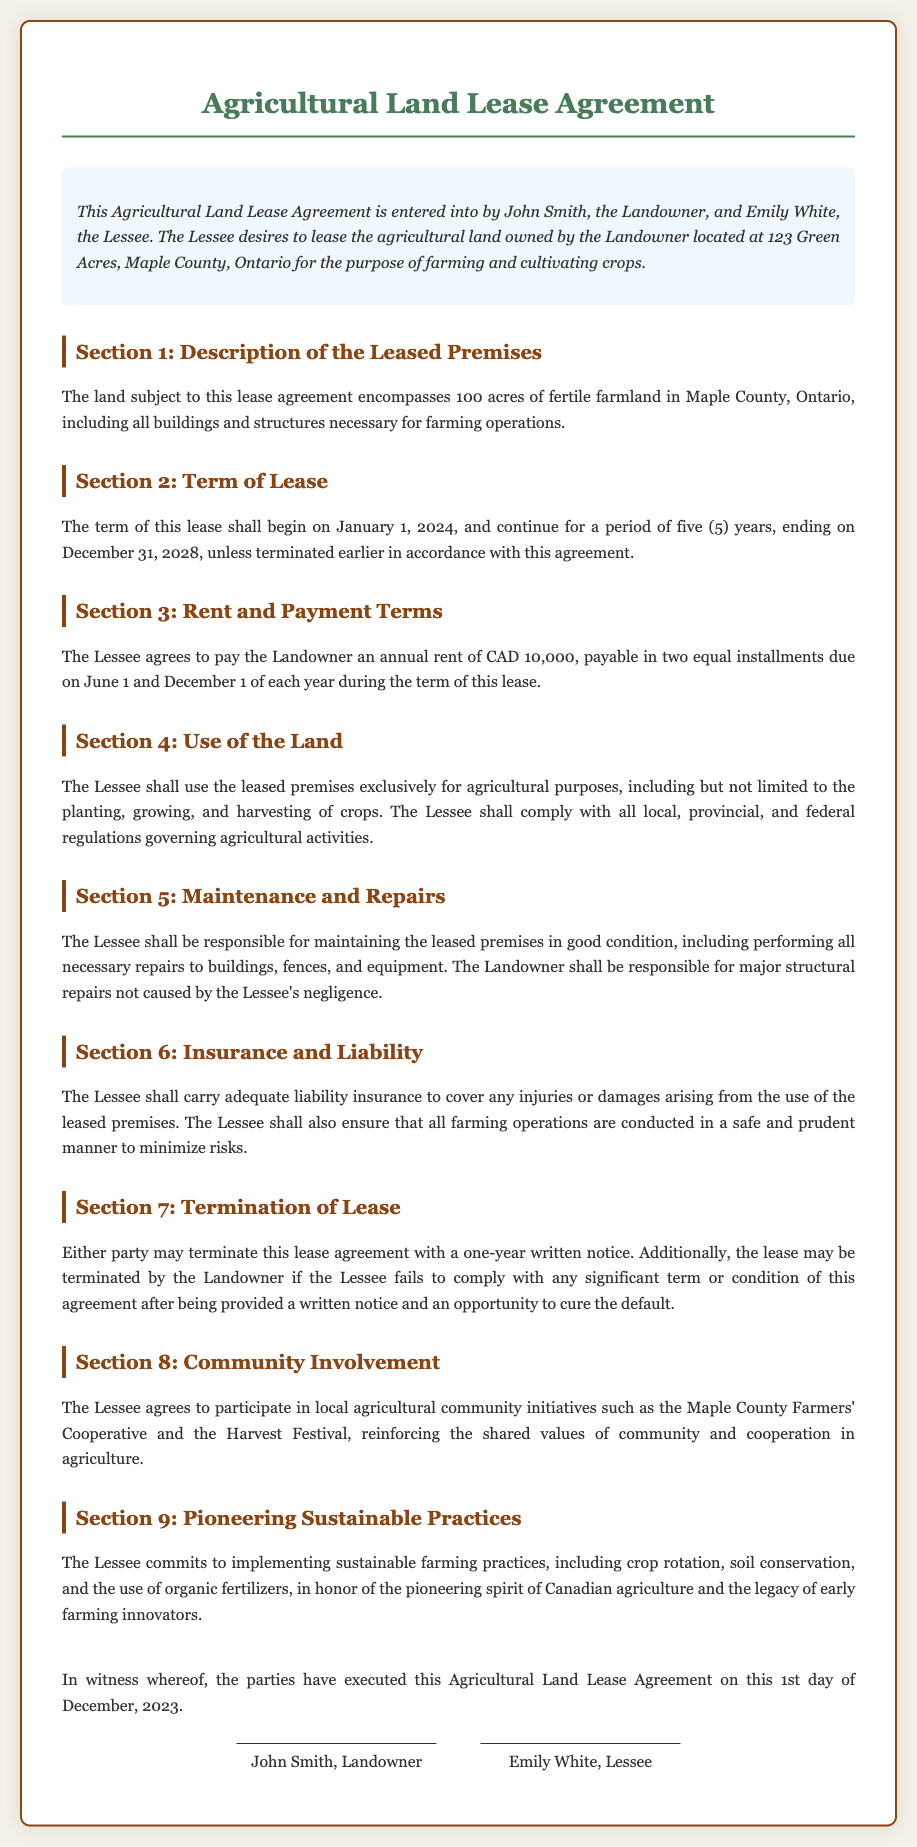What is the name of the Landowner? The Landowner's name is mentioned in the introduction of the document.
Answer: John Smith What is the term of the lease? The term of the lease is specified under the "Term of Lease" section.
Answer: five (5) years What is the annual rent amount? The annual rent amount is detailed in the "Rent and Payment Terms" section.
Answer: CAD 10,000 When does the lease start? The start date of the lease is indicated in the "Term of Lease" section.
Answer: January 1, 2024 What are the Lessee's responsibilities regarding maintenance? The Lessee's responsibilities for maintenance are outlined in the "Maintenance and Repairs" section.
Answer: Maintaining the leased premises in good condition What is required for termination of the lease? The requirements for termination are stated in the "Termination of Lease" section.
Answer: one-year written notice What community initiatives must the Lessee participate in? Community involvement expectations are presented in the "Community Involvement" section.
Answer: Maple County Farmers' Cooperative What sustainable practices must the Lessee implement? The sustainable practices that the Lessee commits to are described in the "Pioneering Sustainable Practices" section.
Answer: crop rotation, soil conservation, organic fertilizers Who are the signatories of the agreement? The signatories of the lease agreement are shown at the end of the document.
Answer: John Smith, Emily White 